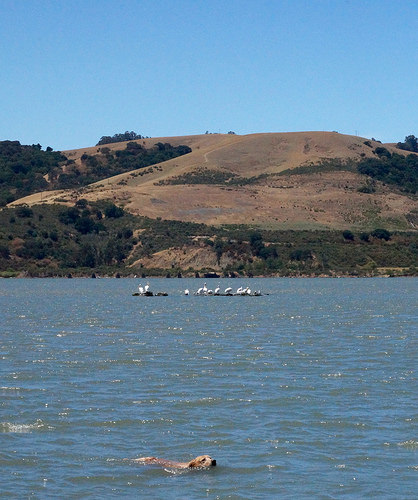<image>
Can you confirm if the dog is behind the mountain? No. The dog is not behind the mountain. From this viewpoint, the dog appears to be positioned elsewhere in the scene. Is there a birds in the water? Yes. The birds is contained within or inside the water, showing a containment relationship. Where is the dog in relation to the water? Is it in front of the water? No. The dog is not in front of the water. The spatial positioning shows a different relationship between these objects. 